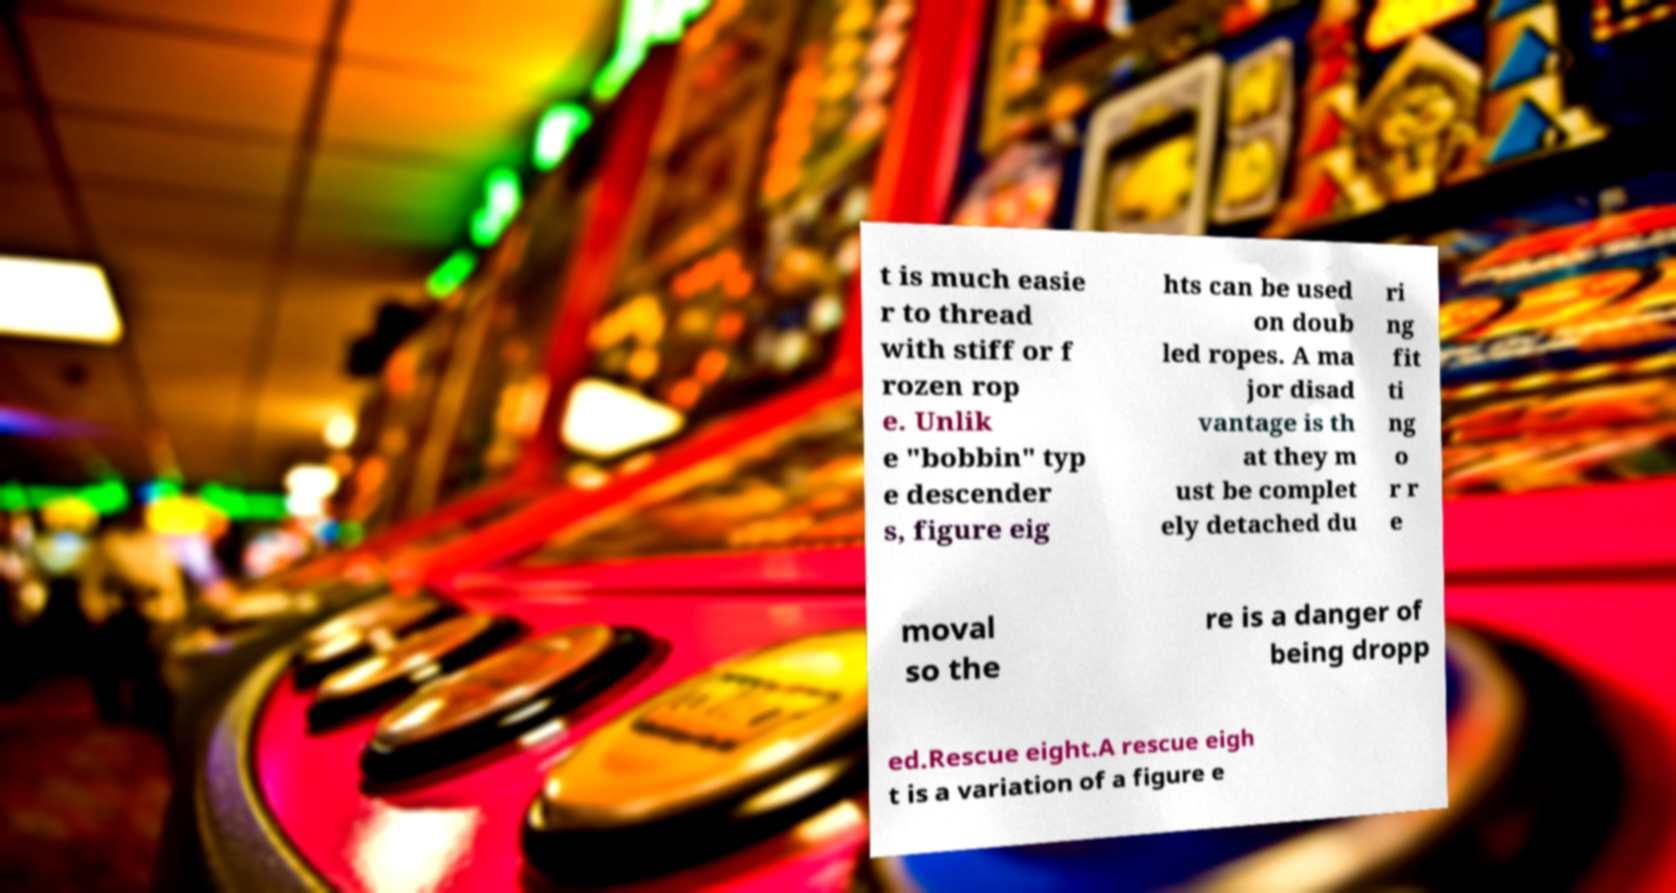Please read and relay the text visible in this image. What does it say? t is much easie r to thread with stiff or f rozen rop e. Unlik e "bobbin" typ e descender s, figure eig hts can be used on doub led ropes. A ma jor disad vantage is th at they m ust be complet ely detached du ri ng fit ti ng o r r e moval so the re is a danger of being dropp ed.Rescue eight.A rescue eigh t is a variation of a figure e 